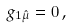<formula> <loc_0><loc_0><loc_500><loc_500>g _ { 1 \hat { \mu } } = 0 \, ,</formula> 